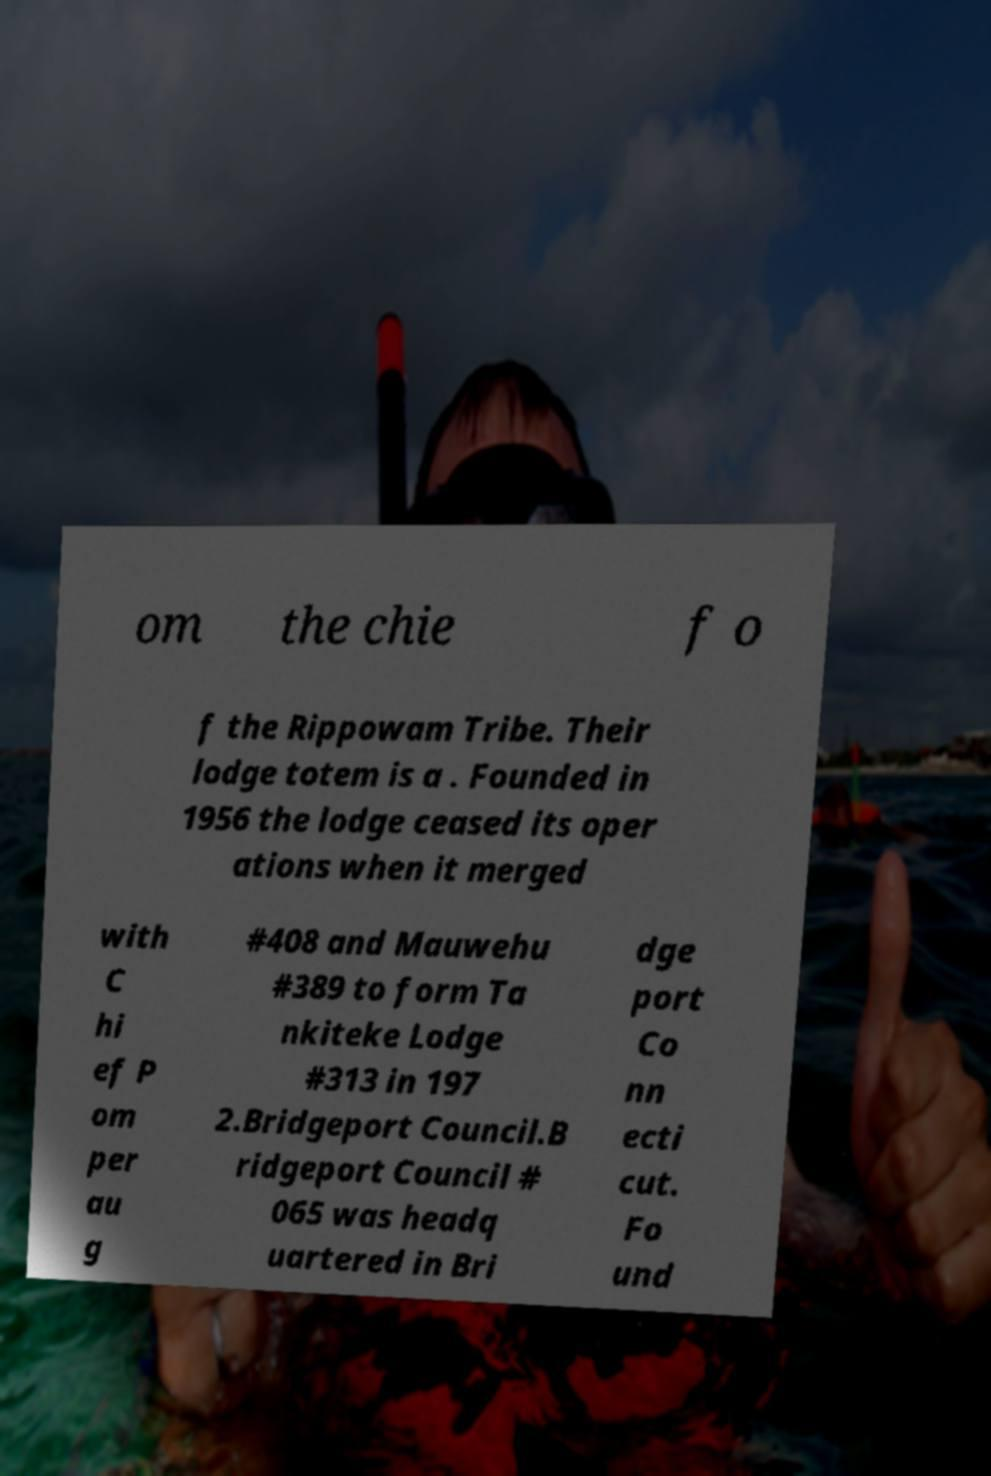For documentation purposes, I need the text within this image transcribed. Could you provide that? om the chie f o f the Rippowam Tribe. Their lodge totem is a . Founded in 1956 the lodge ceased its oper ations when it merged with C hi ef P om per au g #408 and Mauwehu #389 to form Ta nkiteke Lodge #313 in 197 2.Bridgeport Council.B ridgeport Council # 065 was headq uartered in Bri dge port Co nn ecti cut. Fo und 